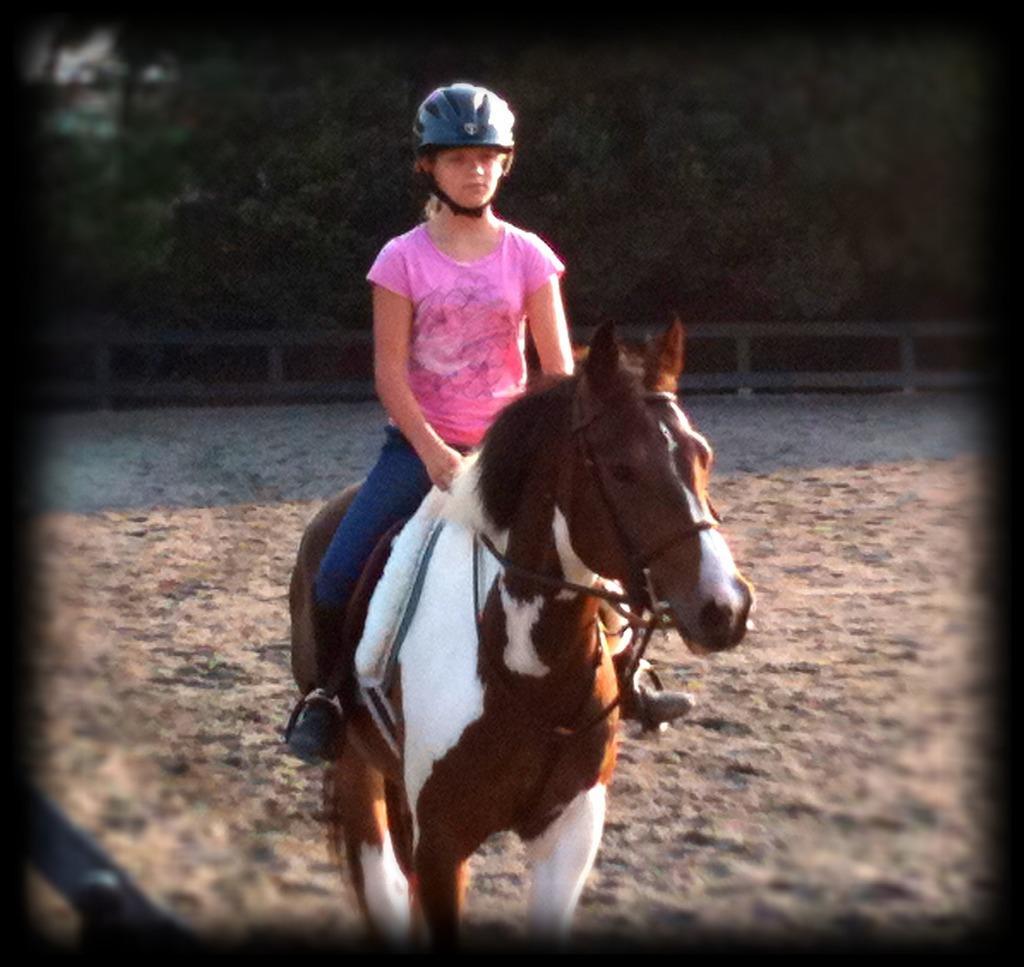In one or two sentences, can you explain what this image depicts? In this image we can see many trees. There is a fencing in the image. A girl is riding a horse. There is an object at the left side of the image. 